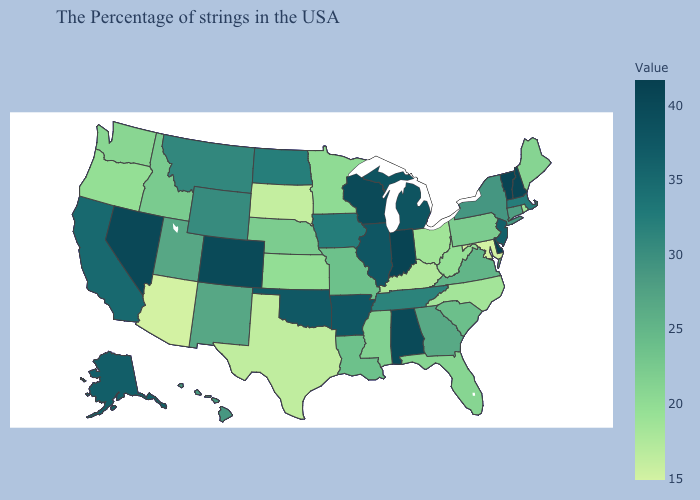Does New York have the highest value in the Northeast?
Concise answer only. No. Does the map have missing data?
Quick response, please. No. Among the states that border Connecticut , does New York have the highest value?
Answer briefly. No. Among the states that border Oregon , does California have the highest value?
Give a very brief answer. No. Does South Dakota have the lowest value in the MidWest?
Be succinct. Yes. Is the legend a continuous bar?
Short answer required. Yes. 